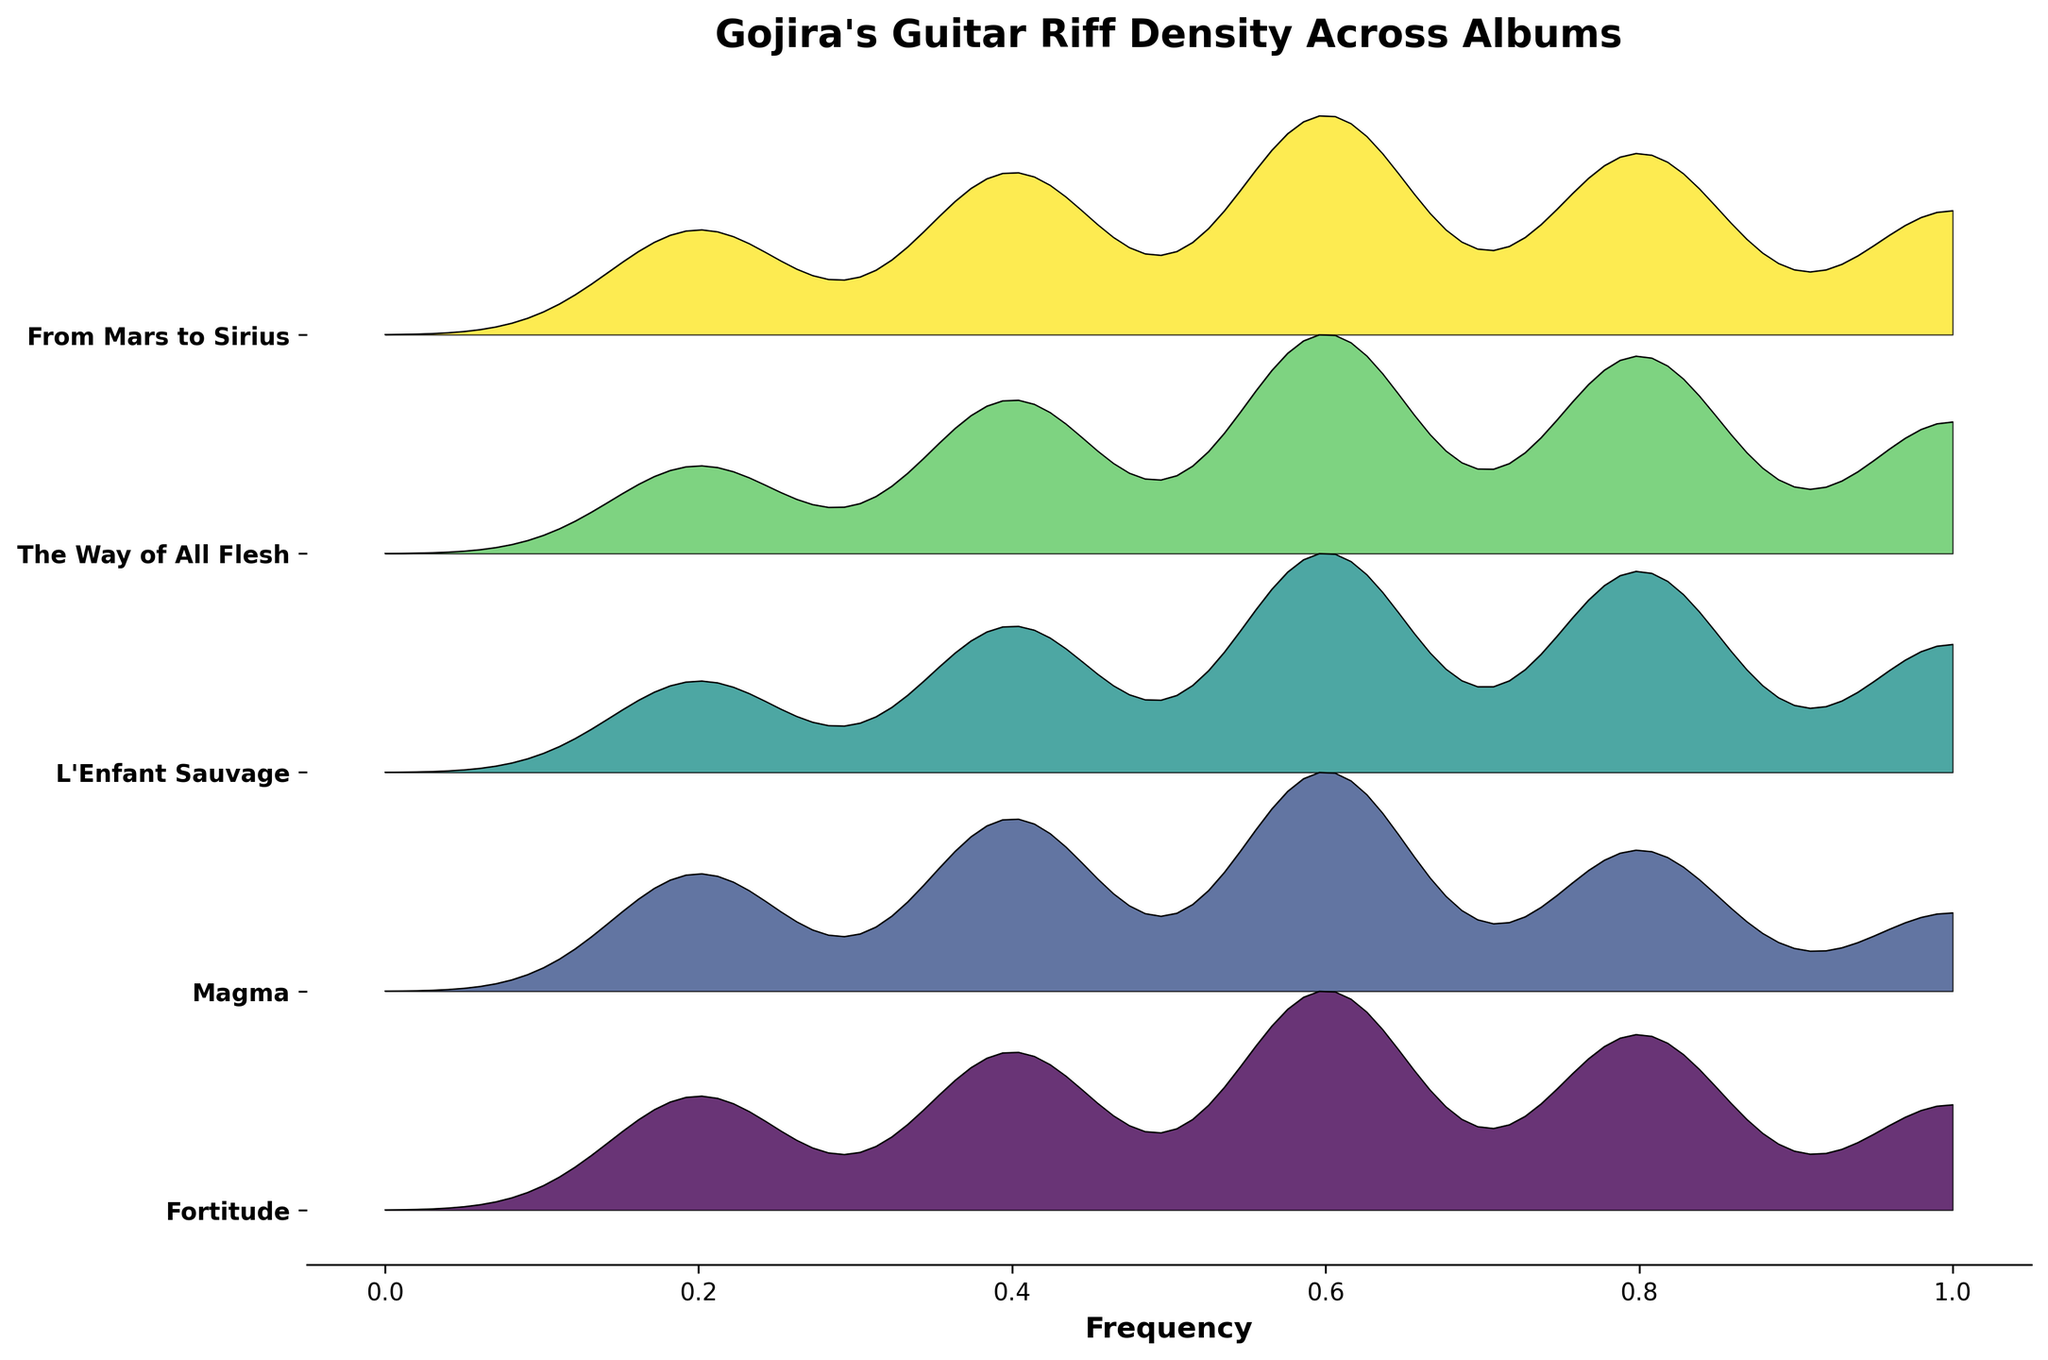What's the title of the plot? The title of the plot is displayed at the top of the figure and usually summarizes the primary subject or data visualized.
Answer: Gojira's Guitar Riff Density Across Albums How many albums are compared in the plot? Count the number of unique entries on the y-axis of the plot, which represents different albums.
Answer: 5 Which album has the highest guitar riff density peak within the frequency range? Observe the peaks of the density distributions for each album. The album with the tallest peak represents the highest density.
Answer: The Way of All Flesh At what frequency does 'From Mars to Sirius' exhibit its highest guitar riff density? Look at the density distribution specific to 'From Mars to Sirius' and identify the frequency associated with the tallest peak.
Answer: 0.6 Comparing 'L'Enfant Sauvage' and 'Magma,' which album has a higher guitar riff density at 0.8 frequency? Trace the density curves for both 'L'Enfant Sauvage' and 'Magma' at the frequency of 0.8 and compare their heights.
Answer: L'Enfant Sauvage What can be said about the riff density trend of 'Magma' from frequencies 0.2 to 1.0? Analyze the density distribution pattern for 'Magma' across the entire frequency range. Notice any increasing, decreasing, or consistent trends.
Answer: The trend generally increases until 0.6 and then decreases Which two albums show a similar riff density pattern? Visually compare the density distributions for all the albums and identify any two that have similar shapes and patterns.
Answer: Magma and Fortitude What does the y-axis represent in this plot? The y-axis labels represent categorical variables in this type of plot.
Answer: The albums Is the riff density of 'The Way of All Flesh' higher at 0.4 or 0.8 frequency? Compare the height of the density curve for 'The Way of All Flesh' at the frequencies 0.4 and 0.8.
Answer: 0.4 At which frequency does 'Fortitude' have the highest guitar riff density peak? Look at the density distribution specific to 'Fortitude' and identify the frequency associated with the tallest peak.
Answer: 0.6 